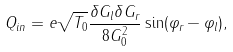<formula> <loc_0><loc_0><loc_500><loc_500>Q _ { i n } = e \sqrt { T _ { 0 } } \frac { \delta G _ { l } \delta G _ { r } } { 8 G _ { 0 } ^ { 2 } } \sin ( \varphi _ { r } - \varphi _ { l } ) ,</formula> 